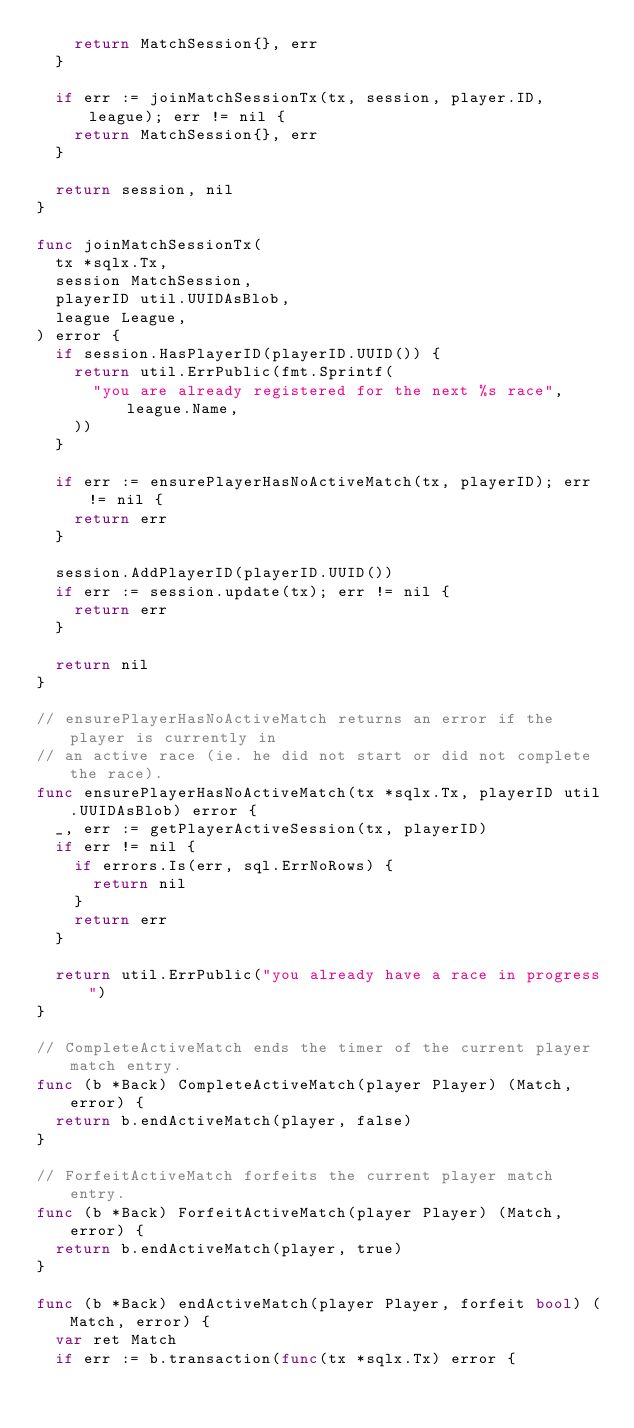Convert code to text. <code><loc_0><loc_0><loc_500><loc_500><_Go_>		return MatchSession{}, err
	}

	if err := joinMatchSessionTx(tx, session, player.ID, league); err != nil {
		return MatchSession{}, err
	}

	return session, nil
}

func joinMatchSessionTx(
	tx *sqlx.Tx,
	session MatchSession,
	playerID util.UUIDAsBlob,
	league League,
) error {
	if session.HasPlayerID(playerID.UUID()) {
		return util.ErrPublic(fmt.Sprintf(
			"you are already registered for the next %s race", league.Name,
		))
	}

	if err := ensurePlayerHasNoActiveMatch(tx, playerID); err != nil {
		return err
	}

	session.AddPlayerID(playerID.UUID())
	if err := session.update(tx); err != nil {
		return err
	}

	return nil
}

// ensurePlayerHasNoActiveMatch returns an error if the player is currently in
// an active race (ie. he did not start or did not complete the race).
func ensurePlayerHasNoActiveMatch(tx *sqlx.Tx, playerID util.UUIDAsBlob) error {
	_, err := getPlayerActiveSession(tx, playerID)
	if err != nil {
		if errors.Is(err, sql.ErrNoRows) {
			return nil
		}
		return err
	}

	return util.ErrPublic("you already have a race in progress")
}

// CompleteActiveMatch ends the timer of the current player match entry.
func (b *Back) CompleteActiveMatch(player Player) (Match, error) {
	return b.endActiveMatch(player, false)
}

// ForfeitActiveMatch forfeits the current player match entry.
func (b *Back) ForfeitActiveMatch(player Player) (Match, error) {
	return b.endActiveMatch(player, true)
}

func (b *Back) endActiveMatch(player Player, forfeit bool) (Match, error) {
	var ret Match
	if err := b.transaction(func(tx *sqlx.Tx) error {</code> 